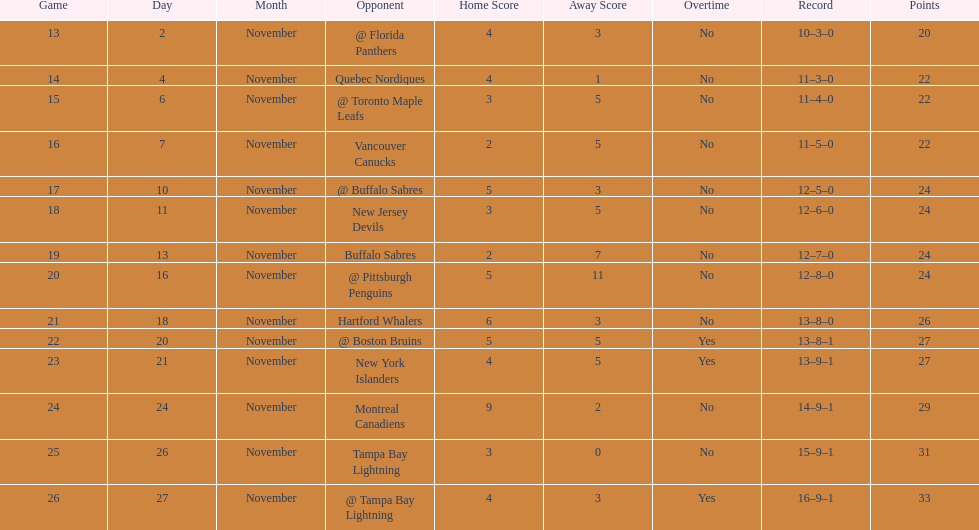Did the tampa bay lightning have the least amount of wins? Yes. 